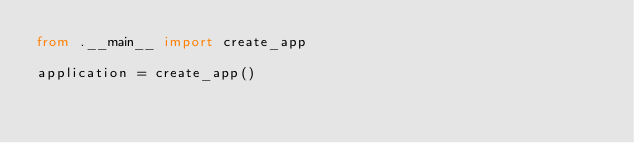Convert code to text. <code><loc_0><loc_0><loc_500><loc_500><_Python_>from .__main__ import create_app

application = create_app()
</code> 